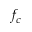<formula> <loc_0><loc_0><loc_500><loc_500>f _ { c }</formula> 